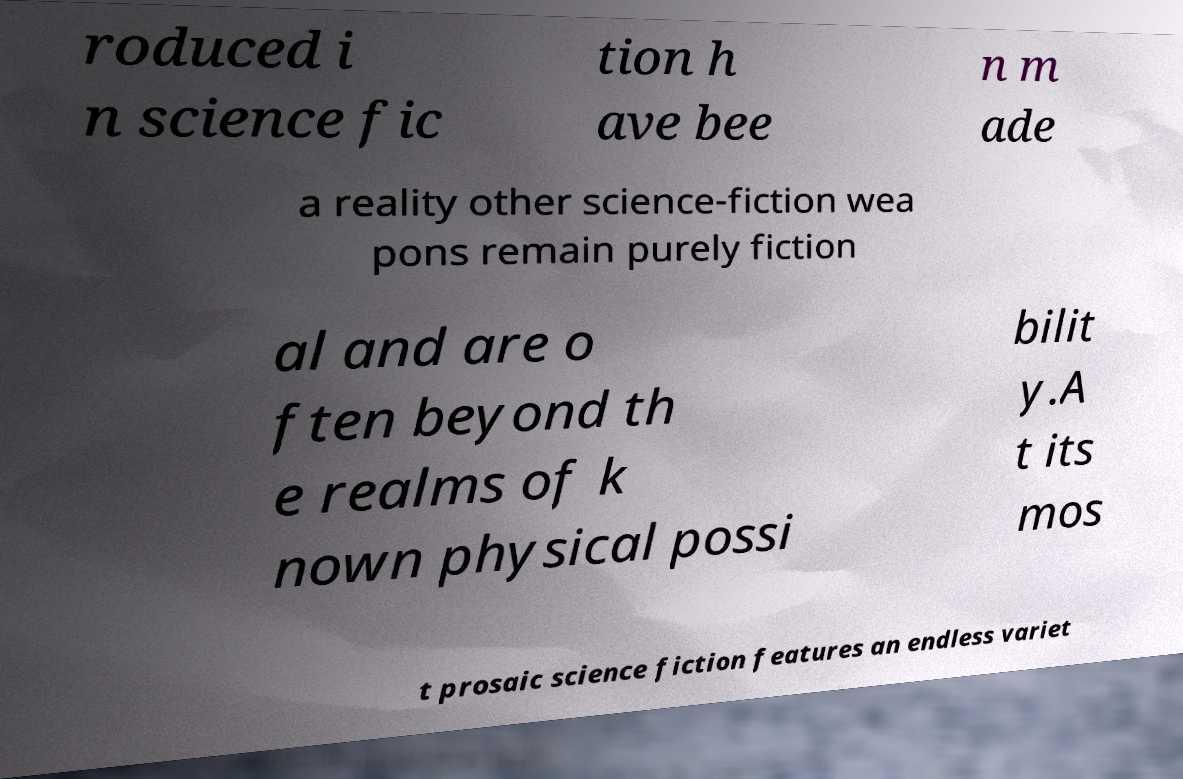What messages or text are displayed in this image? I need them in a readable, typed format. roduced i n science fic tion h ave bee n m ade a reality other science-fiction wea pons remain purely fiction al and are o ften beyond th e realms of k nown physical possi bilit y.A t its mos t prosaic science fiction features an endless variet 